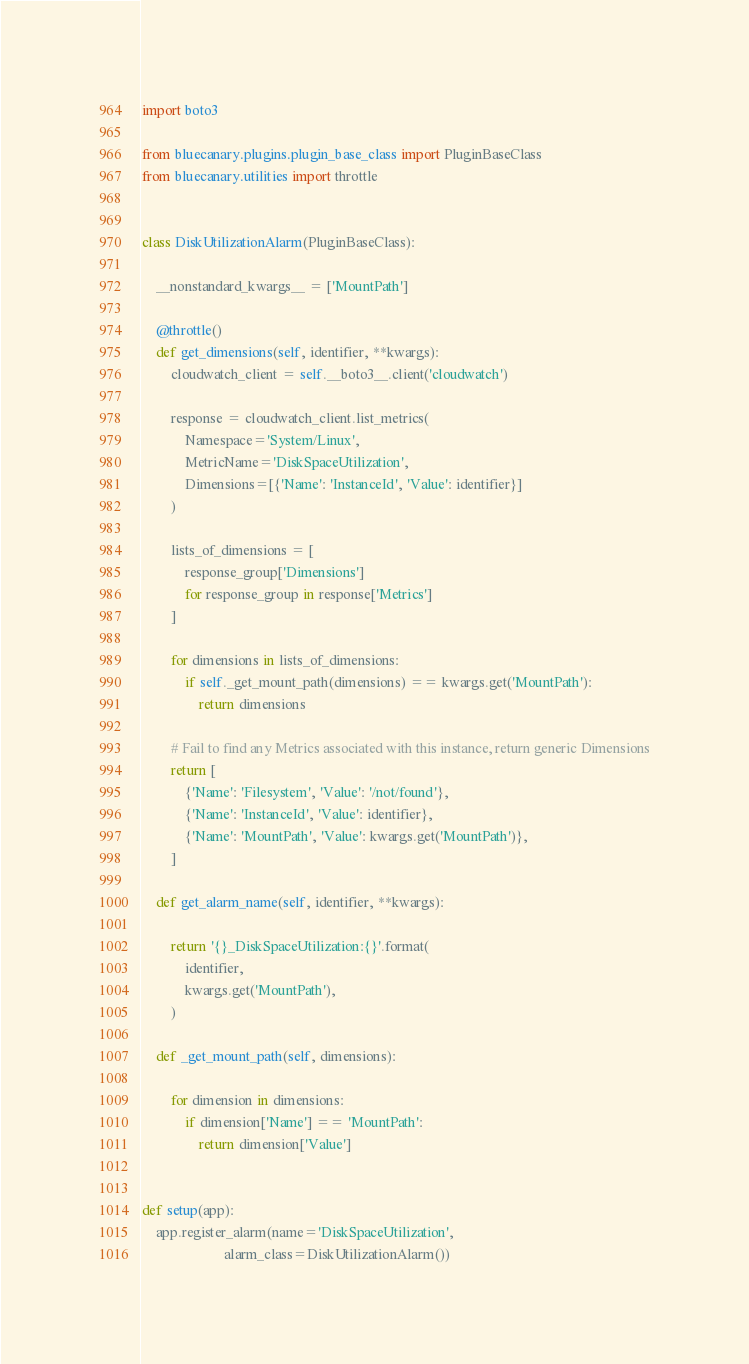<code> <loc_0><loc_0><loc_500><loc_500><_Python_>import boto3

from bluecanary.plugins.plugin_base_class import PluginBaseClass
from bluecanary.utilities import throttle


class DiskUtilizationAlarm(PluginBaseClass):

    __nonstandard_kwargs__ = ['MountPath']

    @throttle()
    def get_dimensions(self, identifier, **kwargs):
        cloudwatch_client = self.__boto3__.client('cloudwatch')

        response = cloudwatch_client.list_metrics(
            Namespace='System/Linux',
            MetricName='DiskSpaceUtilization',
            Dimensions=[{'Name': 'InstanceId', 'Value': identifier}]
        )

        lists_of_dimensions = [
            response_group['Dimensions']
            for response_group in response['Metrics']
        ]

        for dimensions in lists_of_dimensions:
            if self._get_mount_path(dimensions) == kwargs.get('MountPath'):
                return dimensions

        # Fail to find any Metrics associated with this instance, return generic Dimensions
        return [
            {'Name': 'Filesystem', 'Value': '/not/found'},
            {'Name': 'InstanceId', 'Value': identifier},
            {'Name': 'MountPath', 'Value': kwargs.get('MountPath')},
        ]

    def get_alarm_name(self, identifier, **kwargs):

        return '{}_DiskSpaceUtilization:{}'.format(
            identifier,
            kwargs.get('MountPath'),
        )

    def _get_mount_path(self, dimensions):

        for dimension in dimensions:
            if dimension['Name'] == 'MountPath':
                return dimension['Value']


def setup(app):
    app.register_alarm(name='DiskSpaceUtilization',
                       alarm_class=DiskUtilizationAlarm())
</code> 